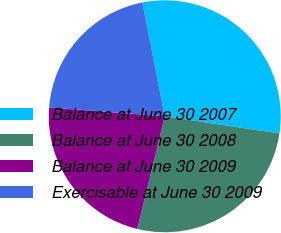Convert chart to OTSL. <chart><loc_0><loc_0><loc_500><loc_500><pie_chart><fcel>Balance at June 30 2007<fcel>Balance at June 30 2008<fcel>Balance at June 30 2009<fcel>Exercisable at June 30 2009<nl><fcel>30.46%<fcel>26.44%<fcel>22.41%<fcel>20.69%<nl></chart> 